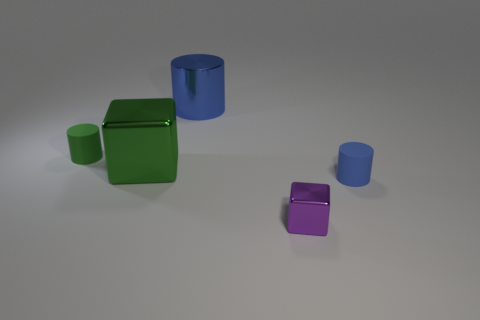What number of tiny cylinders are both right of the tiny purple metal block and on the left side of the metallic cylinder? The number of tiny cylinders located to the right of the tiny purple metal block and simultaneously on the left side of the metallic cylinder is zero. This precise configuration reveals that the spatial relationship between the described objects does not yield any cylinders meeting both criteria. 